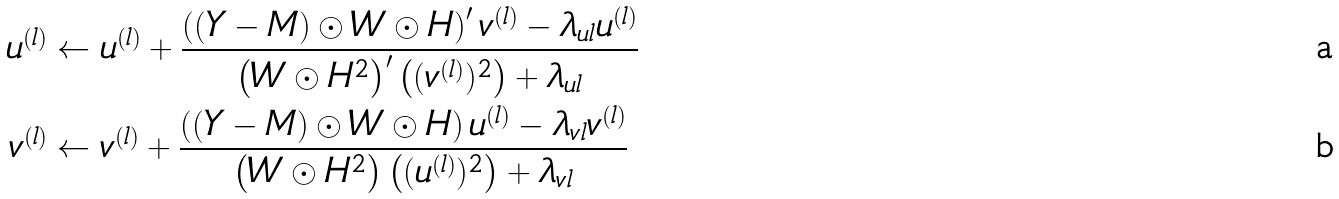Convert formula to latex. <formula><loc_0><loc_0><loc_500><loc_500>u ^ { ( l ) } & \gets u ^ { ( l ) } + \frac { \left ( ( Y - M ) \odot W \odot H \right ) ^ { \prime } v ^ { ( l ) } - \lambda _ { u l } u ^ { ( l ) } } { \left ( W \odot H ^ { 2 } \right ) ^ { \prime } \left ( ( v ^ { ( l ) } ) ^ { 2 } \right ) + \lambda _ { u l } } \\ v ^ { ( l ) } & \gets v ^ { ( l ) } + \frac { \left ( ( Y - M ) \odot W \odot H \right ) u ^ { ( l ) } - \lambda _ { v l } v ^ { ( l ) } } { \left ( W \odot H ^ { 2 } \right ) \left ( ( u ^ { ( l ) } ) ^ { 2 } \right ) + \lambda _ { v l } }</formula> 